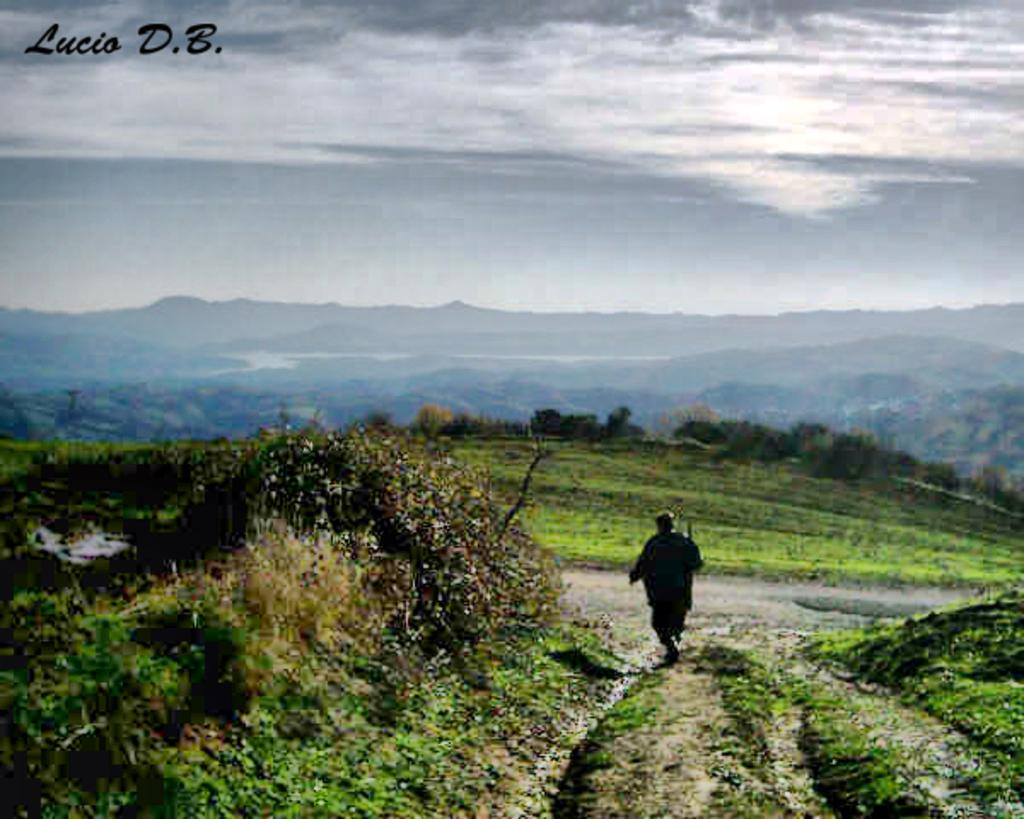What type of landscape can be seen in the image? There are hills in the image. What can be found in the middle of the image? There are trees in the middle of the image. What is visible at the top of the image? The sky is visible at the top of the image. What is written or depicted in the image? There is text in the image. What type of vegetation is present at the bottom of the image? Plants are visible at the bottom of the image. What is the ground cover in the image? Grass is present in the image. How many clocks are visible in the image? There are no clocks present in the image. What type of canvas is used to create the image? The image is not a painting, so there is no canvas involved in its creation. 